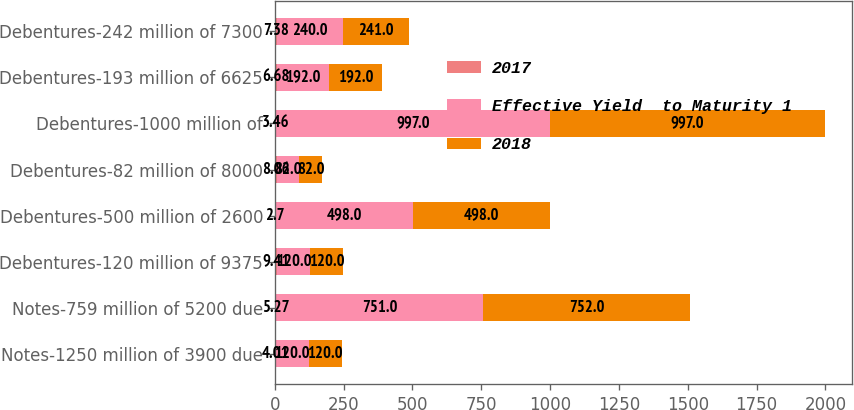Convert chart to OTSL. <chart><loc_0><loc_0><loc_500><loc_500><stacked_bar_chart><ecel><fcel>Notes-1250 million of 3900 due<fcel>Notes-759 million of 5200 due<fcel>Debentures-120 million of 9375<fcel>Debentures-500 million of 2600<fcel>Debentures-82 million of 8000<fcel>Debentures-1000 million of<fcel>Debentures-193 million of 6625<fcel>Debentures-242 million of 7300<nl><fcel>2017<fcel>4.01<fcel>5.27<fcel>9.41<fcel>2.7<fcel>8.06<fcel>3.46<fcel>6.68<fcel>7.38<nl><fcel>Effective Yield  to Maturity 1<fcel>120<fcel>751<fcel>120<fcel>498<fcel>82<fcel>997<fcel>192<fcel>240<nl><fcel>2018<fcel>120<fcel>752<fcel>120<fcel>498<fcel>82<fcel>997<fcel>192<fcel>241<nl></chart> 